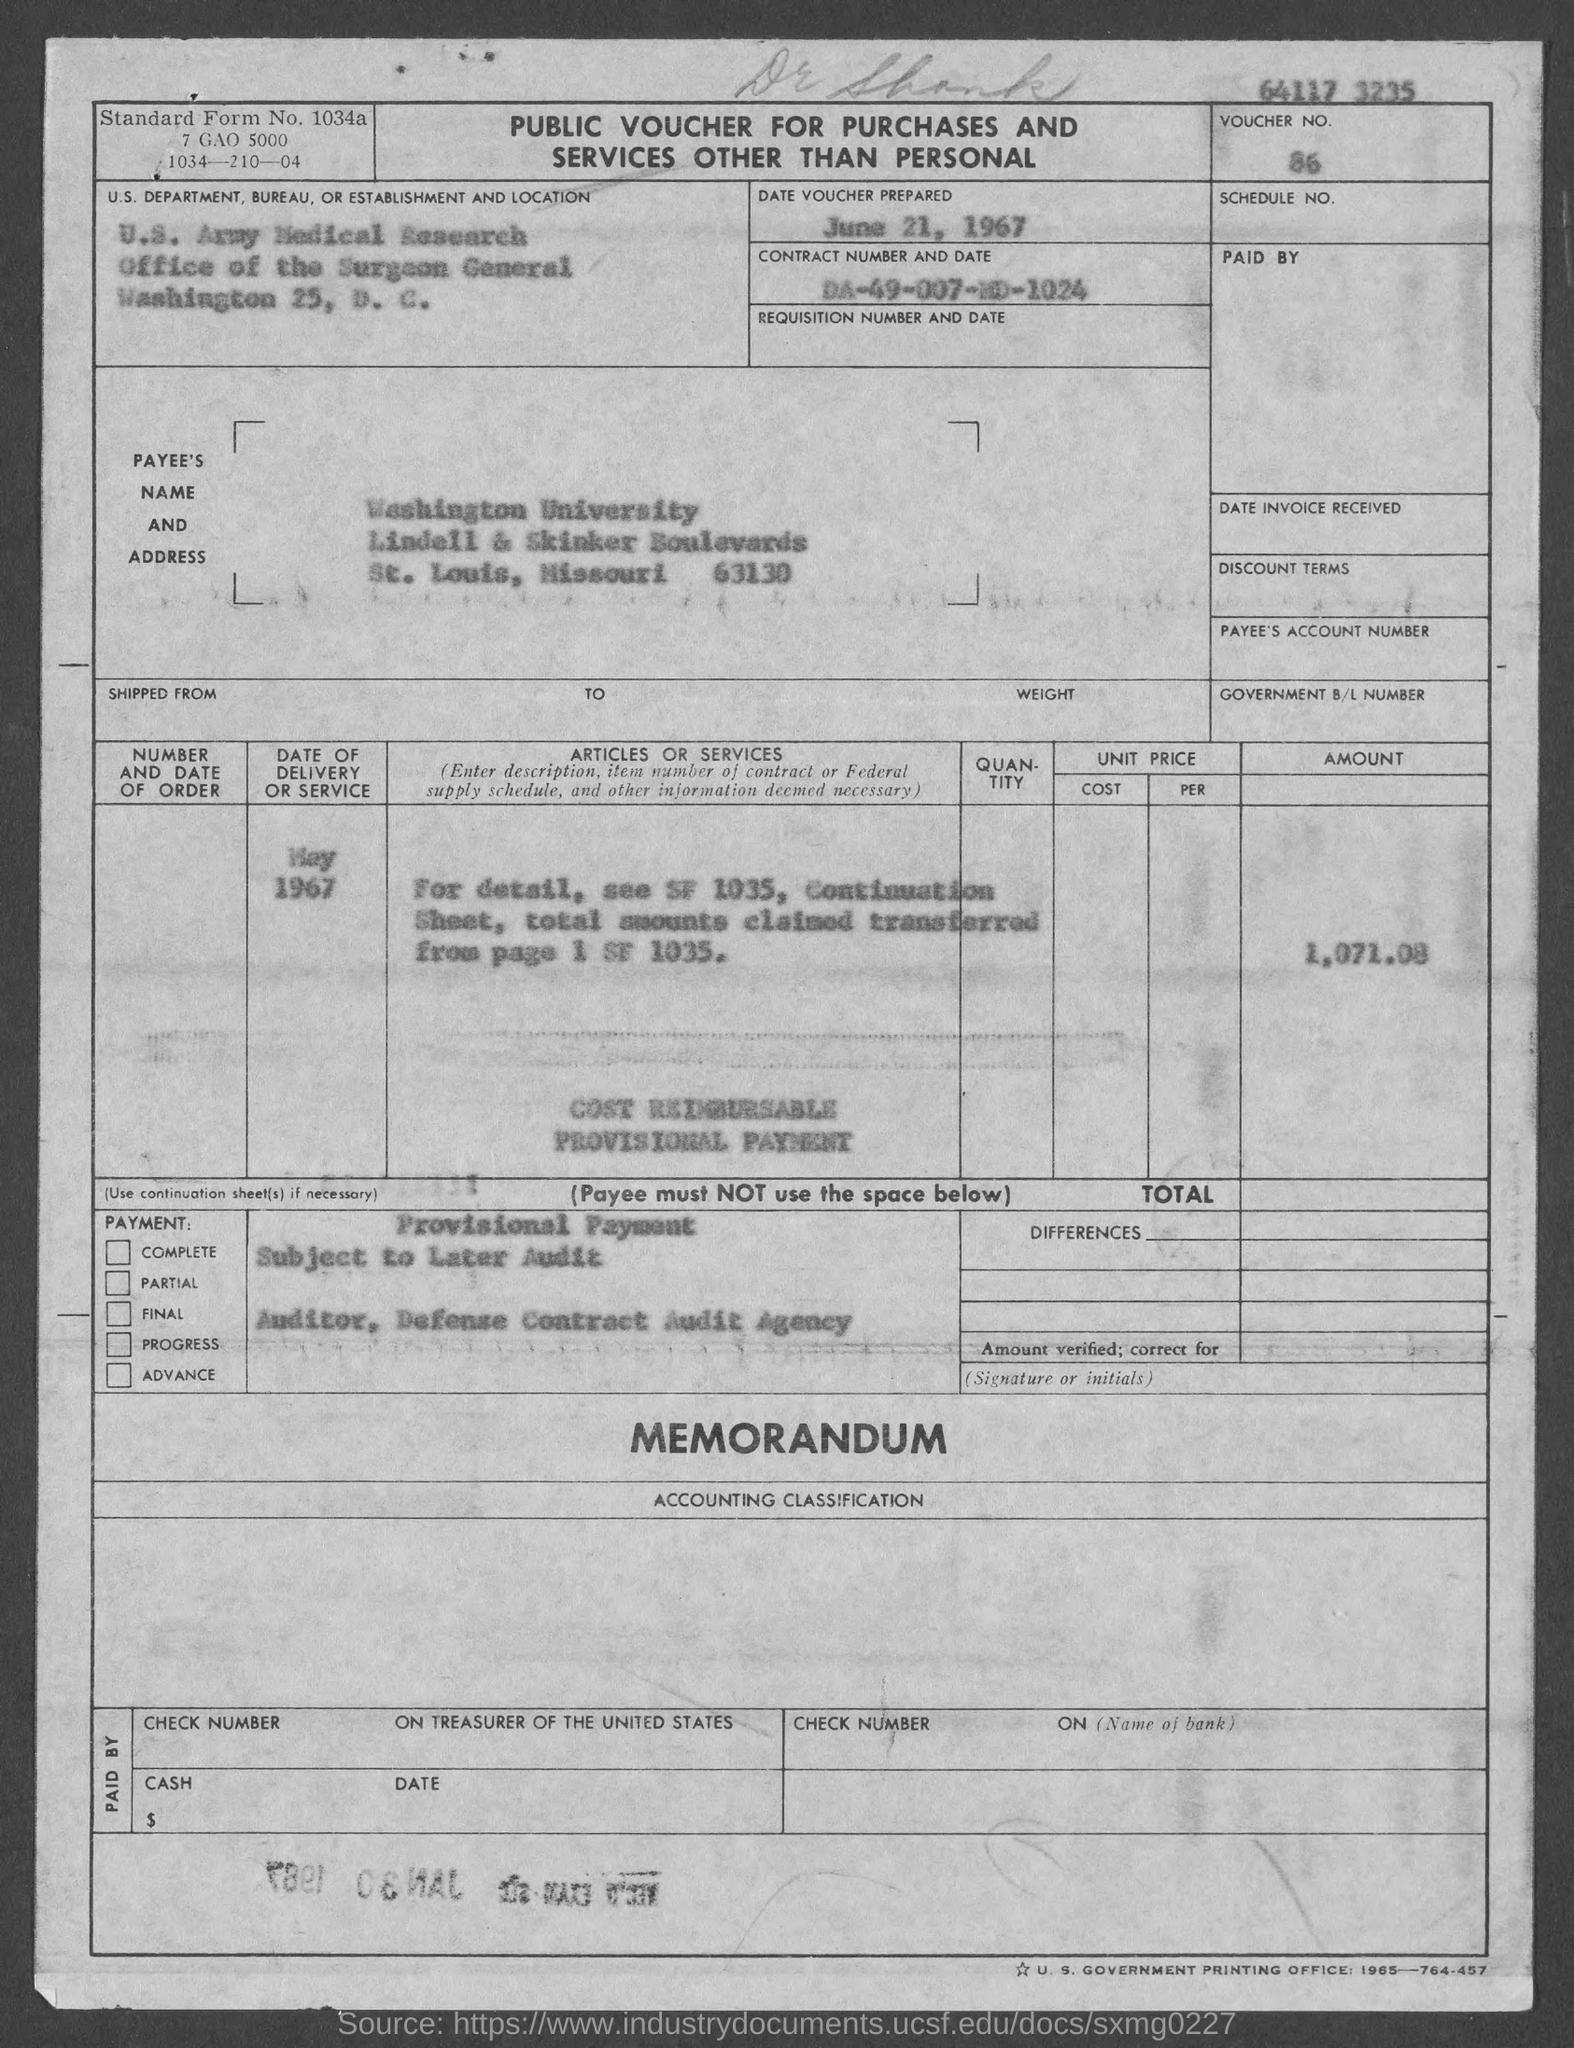What is the date of voucher prepared?
Give a very brief answer. June 21, 1967. What is the Voucher No. mentioned in the document?
Offer a very short reply. 86. What is the Contract Number mentioned in the document?
Give a very brief answer. DA-49-007-MD-1024. What is the Payee's Name given in the voucher?
Your answer should be compact. Washington University. What is the Voucher amount mentioned in the document?
Your answer should be compact. 1,071.08. What is the Standard Form No. given in the voucher?
Ensure brevity in your answer.  1034a. What type of voucher is given here?
Offer a terse response. Public Voucher for Purchases and services other than Personal. 